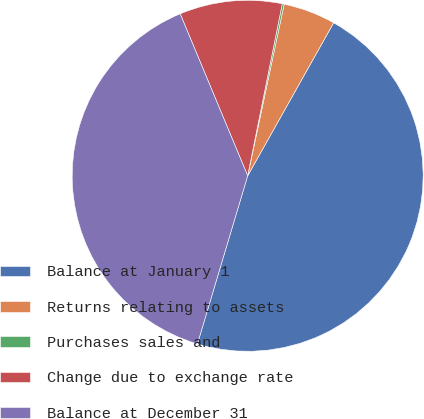Convert chart. <chart><loc_0><loc_0><loc_500><loc_500><pie_chart><fcel>Balance at January 1<fcel>Returns relating to assets<fcel>Purchases sales and<fcel>Change due to exchange rate<fcel>Balance at December 31<nl><fcel>46.47%<fcel>4.81%<fcel>0.18%<fcel>9.44%<fcel>39.09%<nl></chart> 